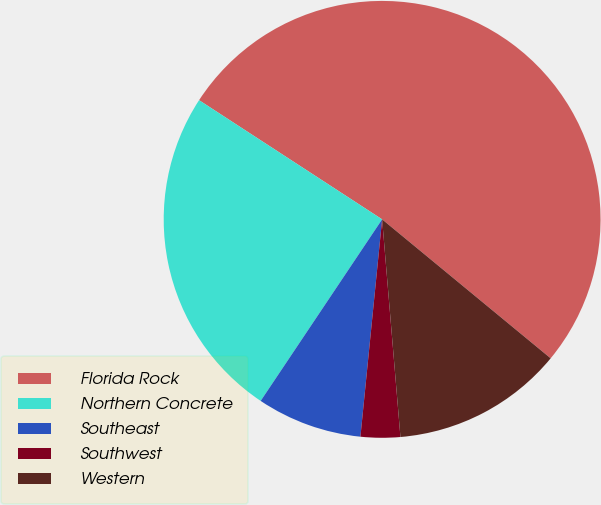Convert chart. <chart><loc_0><loc_0><loc_500><loc_500><pie_chart><fcel>Florida Rock<fcel>Northern Concrete<fcel>Southeast<fcel>Southwest<fcel>Western<nl><fcel>51.79%<fcel>24.8%<fcel>7.8%<fcel>2.92%<fcel>12.69%<nl></chart> 